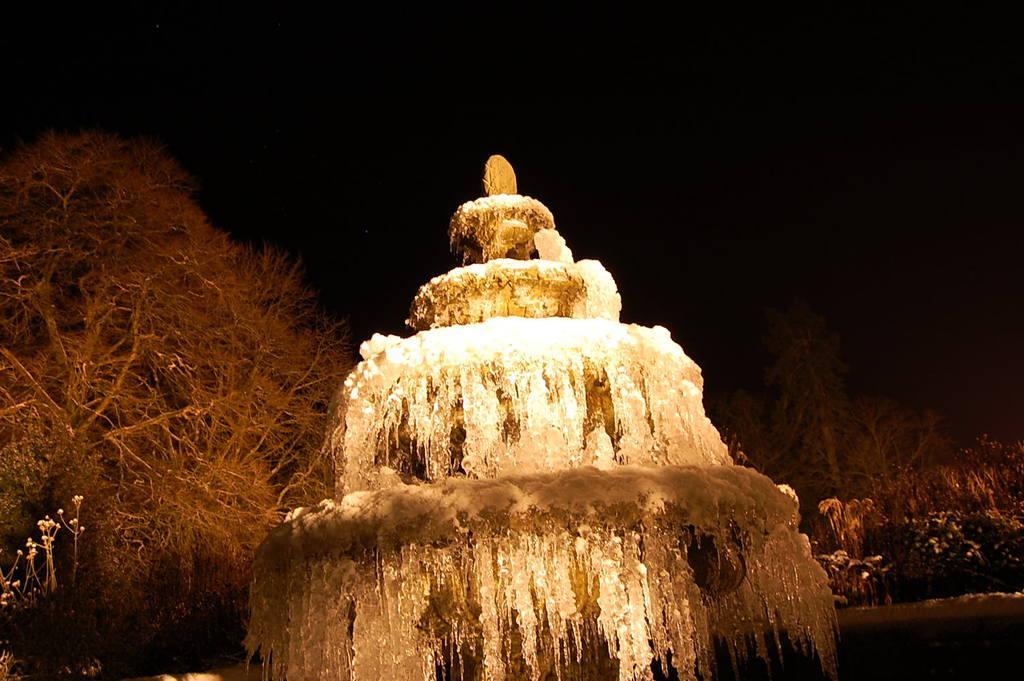What is the main subject of the picture? The main subject of the picture is a water fountain. What can be seen in the background of the picture? There are trees in the background of the picture. What is visible at the top of the picture? The sky is visible at the top of the picture. What type of nail can be seen in the picture? There is no nail present in the picture; it features a water fountain and trees in the background. How does the temper of the water in the fountain change throughout the day? The provided facts do not mention any information about the water's temperature or how it changes throughout the day. 